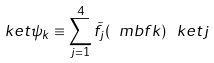<formula> <loc_0><loc_0><loc_500><loc_500>\ k e t { \psi _ { k } } \equiv \sum _ { j = 1 } ^ { 4 } \tilde { f } _ { j } ( \ m b f { k } ) \, \ k e t { j }</formula> 